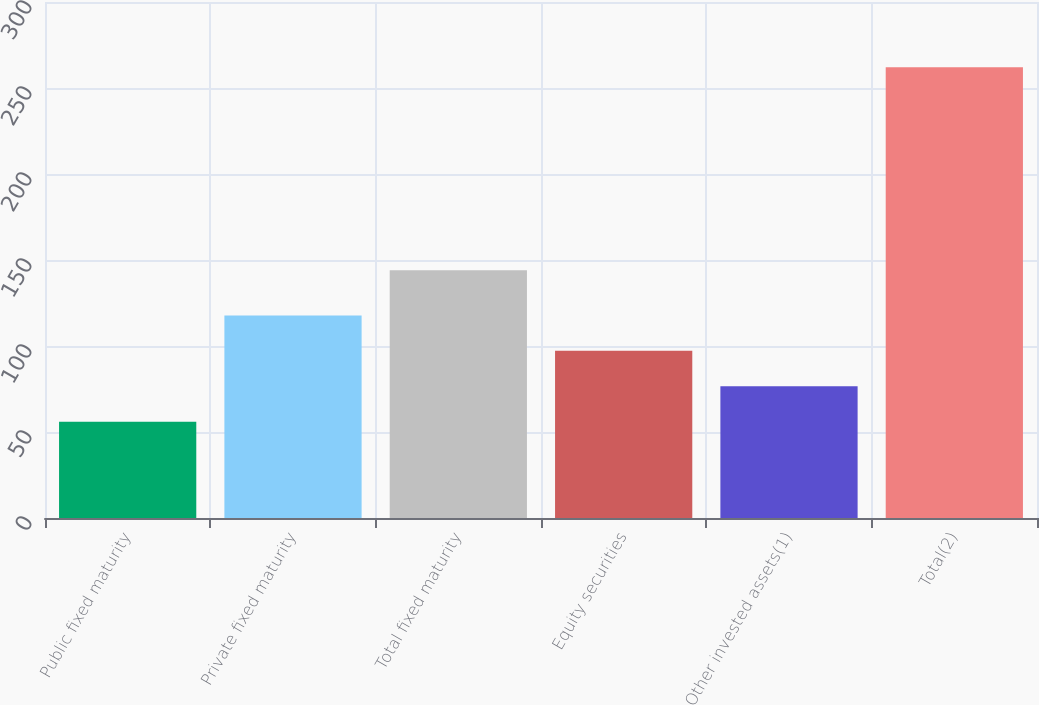<chart> <loc_0><loc_0><loc_500><loc_500><bar_chart><fcel>Public fixed maturity<fcel>Private fixed maturity<fcel>Total fixed maturity<fcel>Equity securities<fcel>Other invested assets(1)<fcel>Total(2)<nl><fcel>56<fcel>117.8<fcel>144<fcel>97.2<fcel>76.6<fcel>262<nl></chart> 